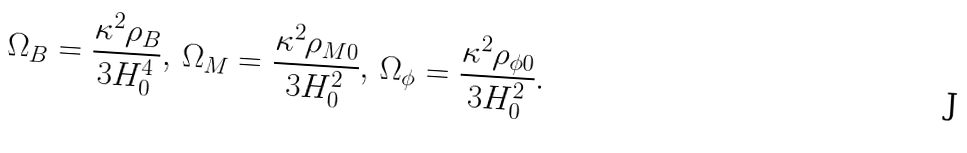Convert formula to latex. <formula><loc_0><loc_0><loc_500><loc_500>\Omega _ { B } = \frac { \kappa ^ { 2 } \rho _ { B } } { 3 H _ { 0 } ^ { 4 } } , \, \Omega _ { M } = \frac { \kappa ^ { 2 } \rho _ { M 0 } } { 3 H _ { 0 } ^ { 2 } } , \, \Omega _ { \phi } = \frac { \kappa ^ { 2 } \rho _ { \phi 0 } } { 3 H _ { 0 } ^ { 2 } } .</formula> 